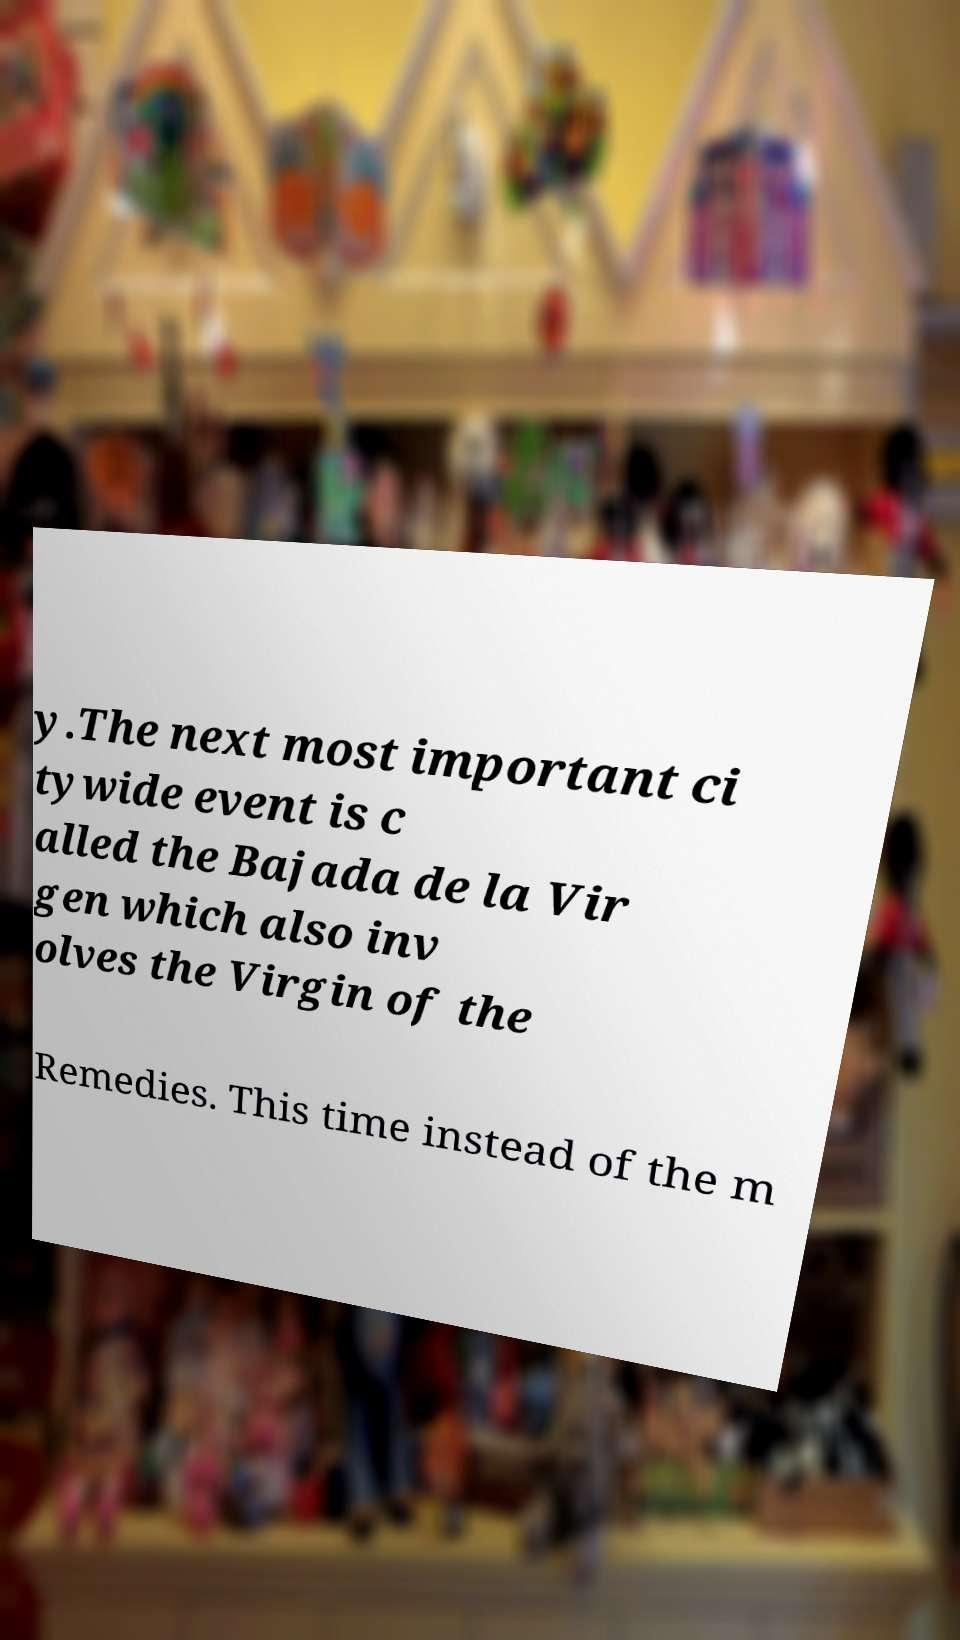Please read and relay the text visible in this image. What does it say? y.The next most important ci tywide event is c alled the Bajada de la Vir gen which also inv olves the Virgin of the Remedies. This time instead of the m 